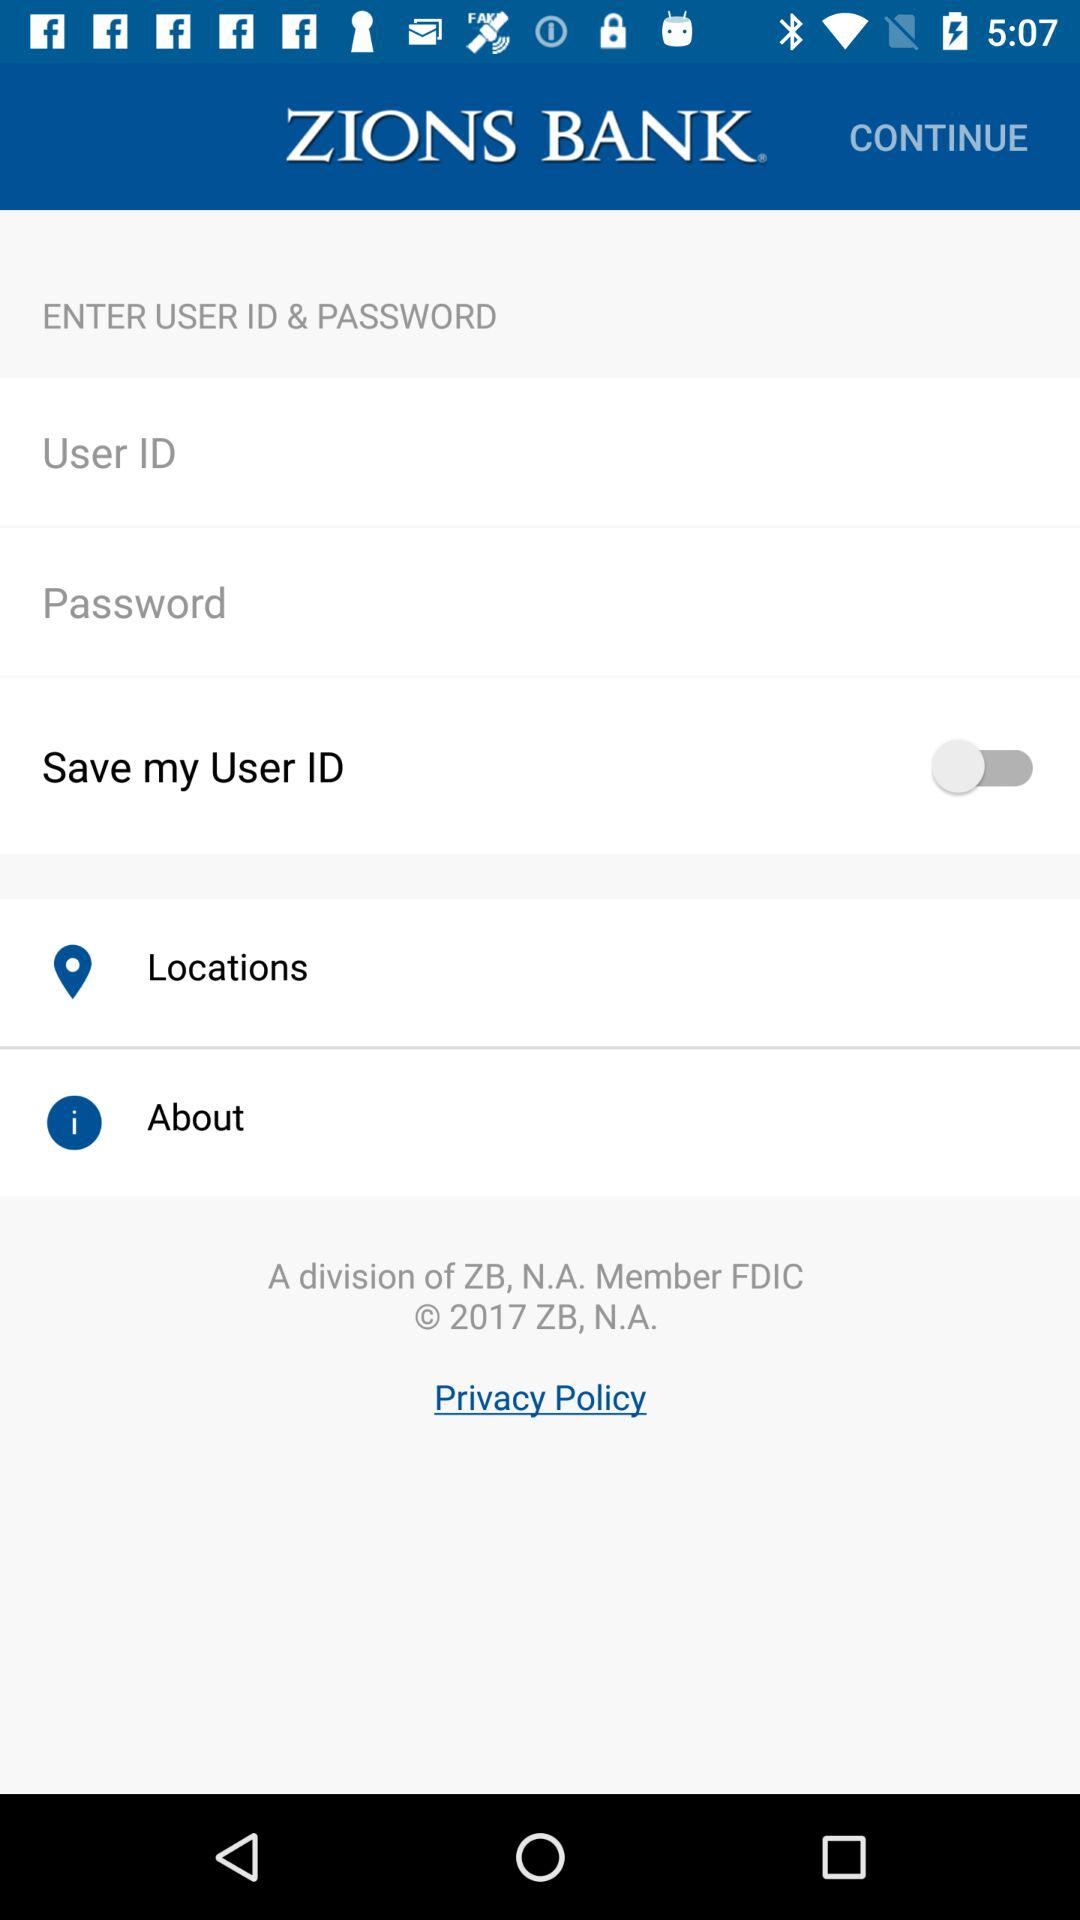What is the status of "Save my User ID"? The status is "off". 